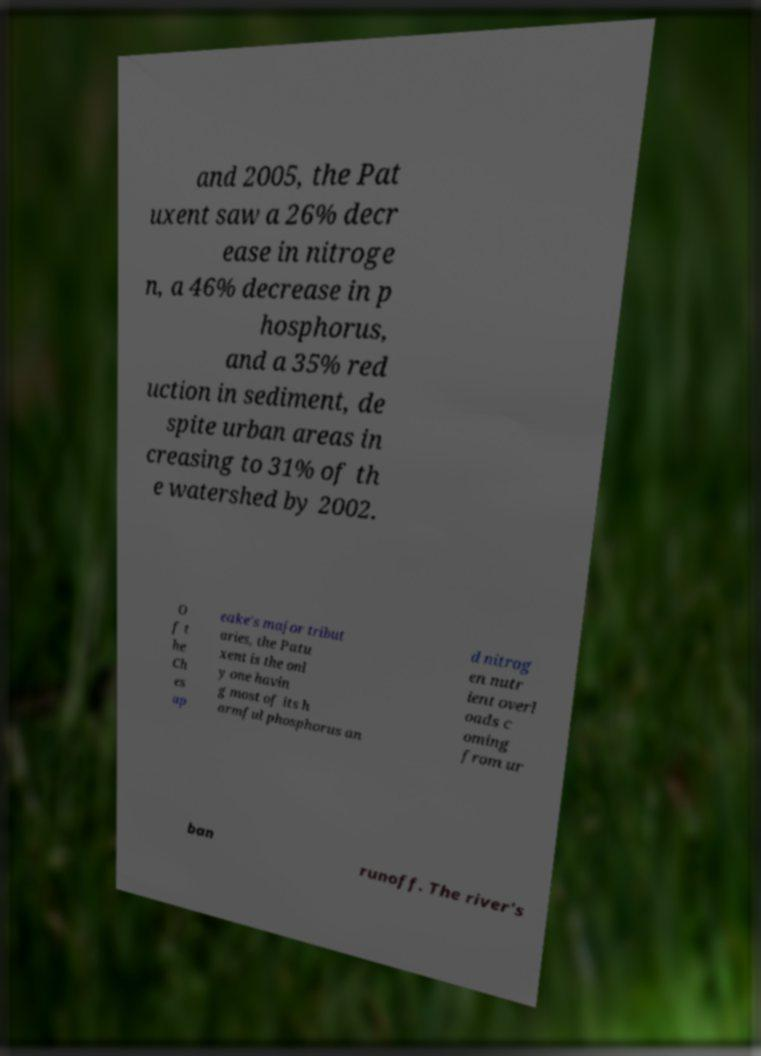There's text embedded in this image that I need extracted. Can you transcribe it verbatim? and 2005, the Pat uxent saw a 26% decr ease in nitroge n, a 46% decrease in p hosphorus, and a 35% red uction in sediment, de spite urban areas in creasing to 31% of th e watershed by 2002. O f t he Ch es ap eake's major tribut aries, the Patu xent is the onl y one havin g most of its h armful phosphorus an d nitrog en nutr ient overl oads c oming from ur ban runoff. The river's 